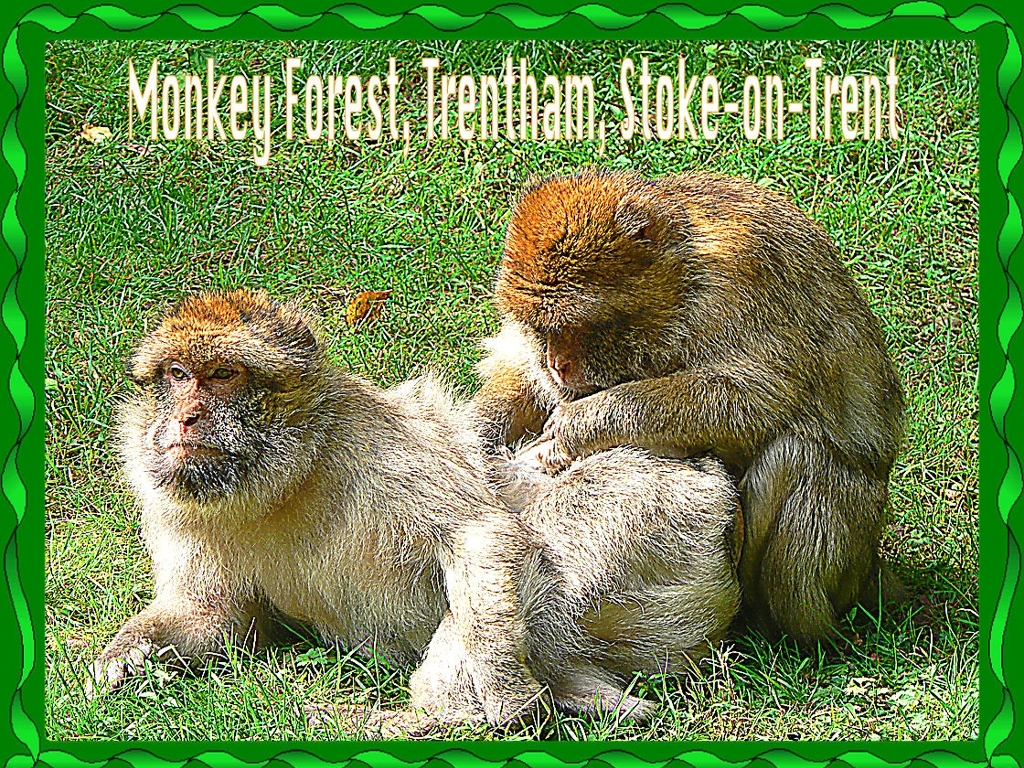What species of monkey is this, and where can you typically find them? These are Barbary macaques, a species of macaque with no tail. They are native to the Atlas Mountains of Algeria and Morocco, with a small population in Gibraltar. They typically live in mountainous areas and forests where they can find ample food and shelter. What do Barbary macaques typically eat? Barbary macaques are omnivores and have a varied diet that consists of leaves, roots, and fruit. They also eat insects and small animals when available. Their diet can vary depending on the season and availability of food resources. 